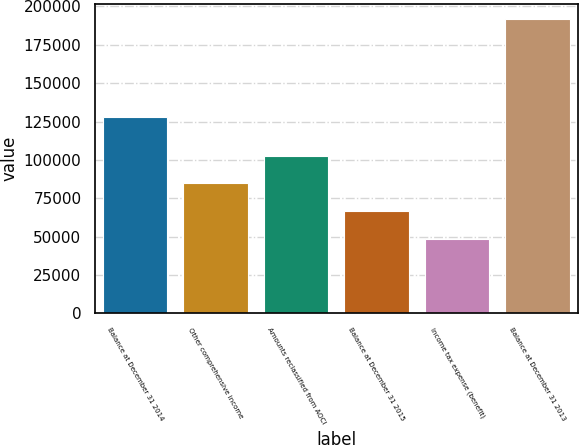<chart> <loc_0><loc_0><loc_500><loc_500><bar_chart><fcel>Balance at December 31 2014<fcel>Other comprehensive income<fcel>Amounts reclassified from AOCI<fcel>Balance at December 31 2015<fcel>Income tax expense (benefit)<fcel>Balance at December 31 2013<nl><fcel>128041<fcel>84739.4<fcel>102877<fcel>66602.2<fcel>48465<fcel>192101<nl></chart> 